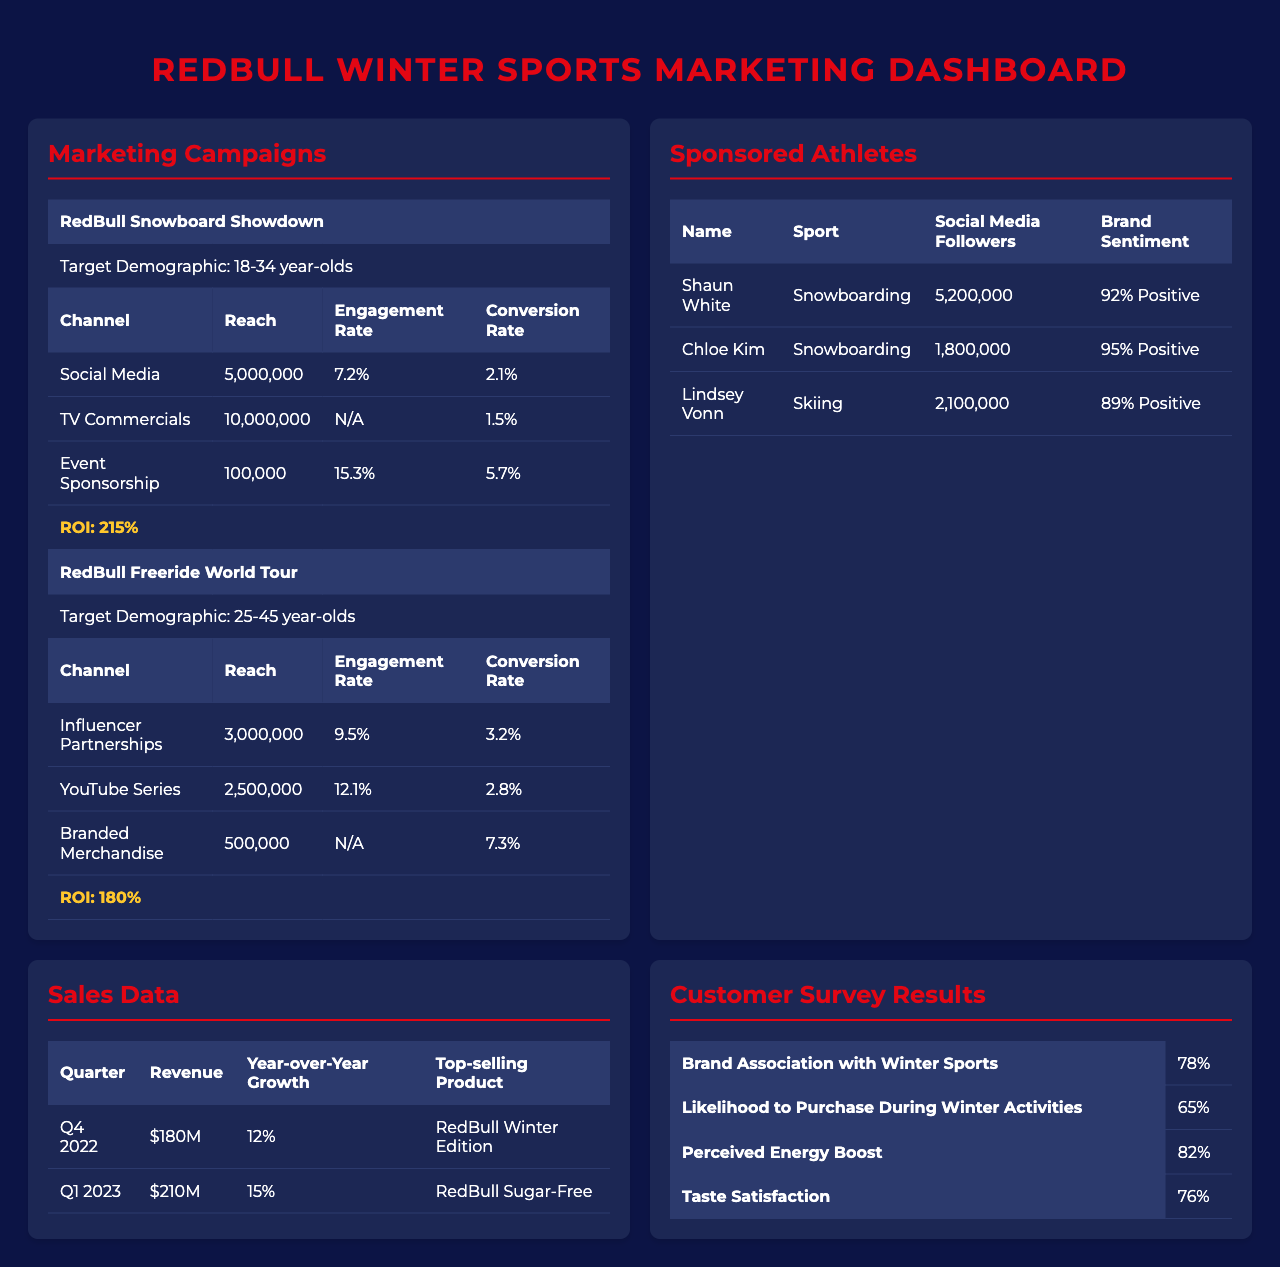What is the ROI for the RedBull Snowboard Showdown campaign? The table shows that the ROI for the RedBull Snowboard Showdown campaign is 215%.
Answer: 215% What is the conversion rate for the Event Sponsorship channel in the RedBull Snowboard Showdown campaign? The conversion rate for the Event Sponsorship channel in the RedBull Snowboard Showdown campaign is 5.7%.
Answer: 5.7% How many followers does Shaun White have on social media? The table lists Shaun White's social media followers as 5,200,000.
Answer: 5,200,000 Which campaign has a higher engagement rate, RedBull Freeride World Tour or RedBull Snowboard Showdown? The engagement rate for RedBull Freeride World Tour is 12.1%, while for RedBull Snowboard Showdown it is 7.2%. Therefore, the RedBull Freeride World Tour has a higher engagement rate.
Answer: RedBull Freeride World Tour What is the sum of reaches for channels under the RedBull Freeride World Tour campaign? The reach for Influencer Partnerships is 3,000,000, for YouTube Series it's 2,500,000, and for Branded Merchandise it's 500,000. Summing these values gives 3,000,000 + 2,500,000 + 500,000 = 6,000,000.
Answer: 6,000,000 Is the brand sentiment for Chloe Kim higher than that for Lindsey Vonn? Chloe Kim's brand sentiment is 95% positive, while Lindsey Vonn's is 89% positive. Since 95% is greater than 89%, Chloe Kim's brand sentiment is indeed higher.
Answer: Yes What percentage of customers associate the RedBull brand with winter sports? According to the customer survey results, 78% of customers associate the RedBull brand with winter sports.
Answer: 78% Which channel in the RedBull Snowboard Showdown campaign had the highest engagement rate? The Event Sponsorship channel had the highest engagement rate at 15.3%.
Answer: Event Sponsorship What is the average year-over-year growth from Q4 2022 to Q1 2023? The year-over-year growth for Q4 2022 is 12%, and for Q1 2023 it is 15%. The average is (12% + 15%) / 2 = 13.5%.
Answer: 13.5% What is the top-selling product in Q1 2023? The top-selling product in Q1 2023 is RedBull Sugar-Free.
Answer: RedBull Sugar-Free Is the reach for TV Commercials in the RedBull Snowboard Showdown campaign higher than that for Influencer Partnerships in the RedBull Freeride World Tour campaign? The reach for TV Commercials is 10,000,000, whereas the reach for Influencer Partnerships is 3,000,000. Since 10,000,000 is greater than 3,000,000, the reach for TV Commercials is higher.
Answer: Yes 